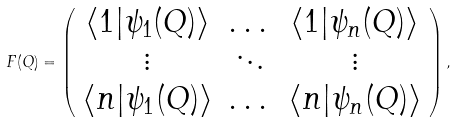Convert formula to latex. <formula><loc_0><loc_0><loc_500><loc_500>F ( Q ) = \left ( \begin{array} { c c c } \langle 1 | \psi _ { 1 } ( Q ) \rangle & \dots & \langle 1 | \psi _ { n } ( Q ) \rangle \\ \vdots & \ddots & \vdots \\ \langle n | \psi _ { 1 } ( Q ) \rangle & \dots & \langle n | \psi _ { n } ( Q ) \rangle \\ \end{array} \right ) ,</formula> 